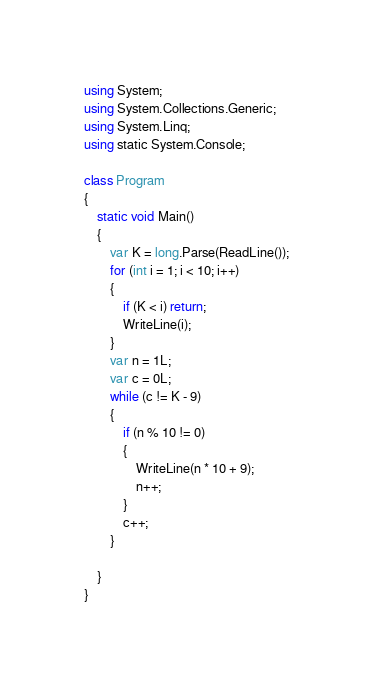Convert code to text. <code><loc_0><loc_0><loc_500><loc_500><_C#_>using System;
using System.Collections.Generic;
using System.Linq;
using static System.Console;

class Program
{
    static void Main()
    {
        var K = long.Parse(ReadLine());
        for (int i = 1; i < 10; i++)
        {
            if (K < i) return;
            WriteLine(i);
        }
        var n = 1L;
        var c = 0L;
        while (c != K - 9)
        {
            if (n % 10 != 0)
            {
                WriteLine(n * 10 + 9);
                n++;
            }
            c++;
        }

    }
}</code> 